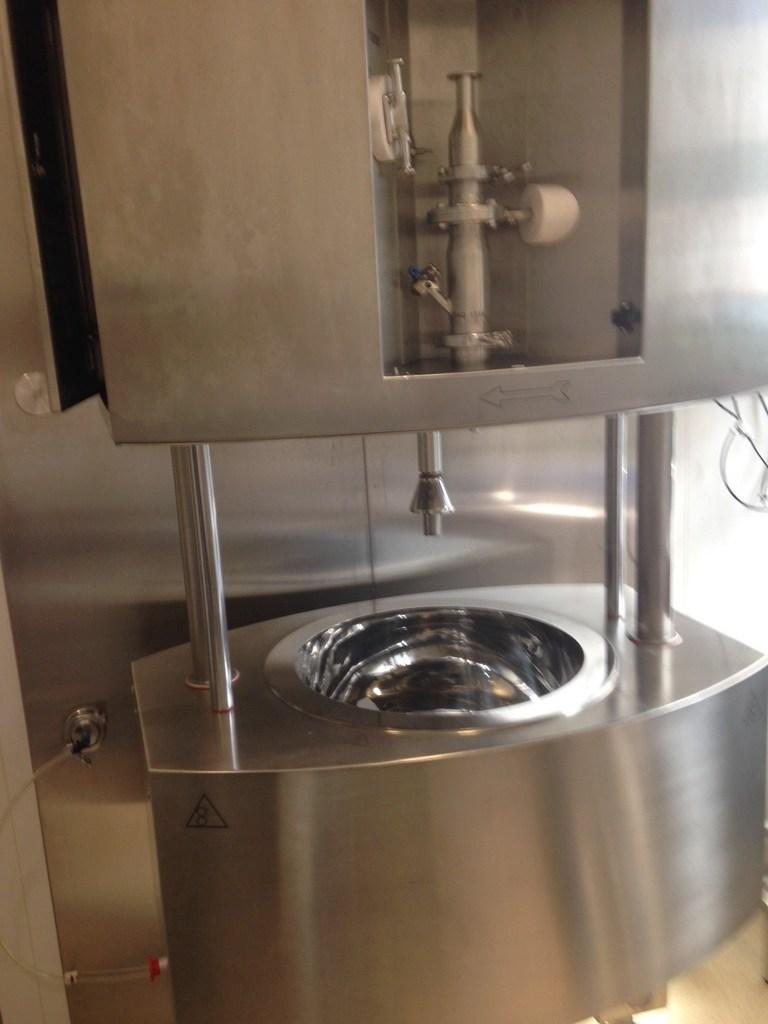How would you summarize this image in a sentence or two? In this image there is a machine which is made up of metal. 